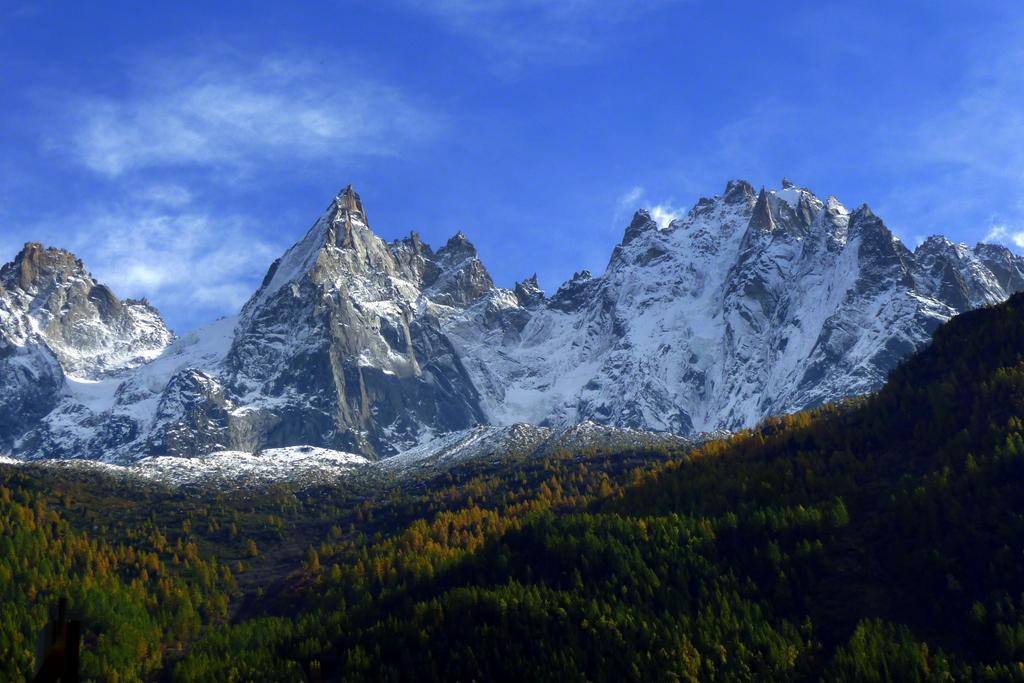Describe this image in one or two sentences. There is greenery at the bottom side of the image, there are mountains and sky in the background area, it seems like snow on the mountains. 